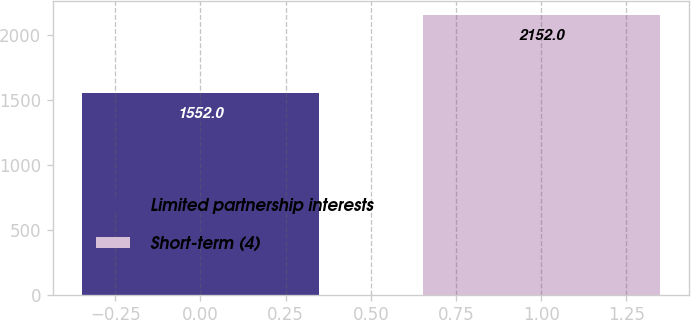Convert chart to OTSL. <chart><loc_0><loc_0><loc_500><loc_500><bar_chart><fcel>Limited partnership interests<fcel>Short-term (4)<nl><fcel>1552<fcel>2152<nl></chart> 